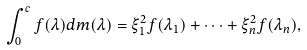<formula> <loc_0><loc_0><loc_500><loc_500>\int _ { 0 } ^ { c } f ( \lambda ) d m ( \lambda ) = \xi _ { 1 } ^ { 2 } f ( \lambda _ { 1 } ) + \dots + \xi _ { n } ^ { 2 } f ( \lambda _ { n } ) ,</formula> 